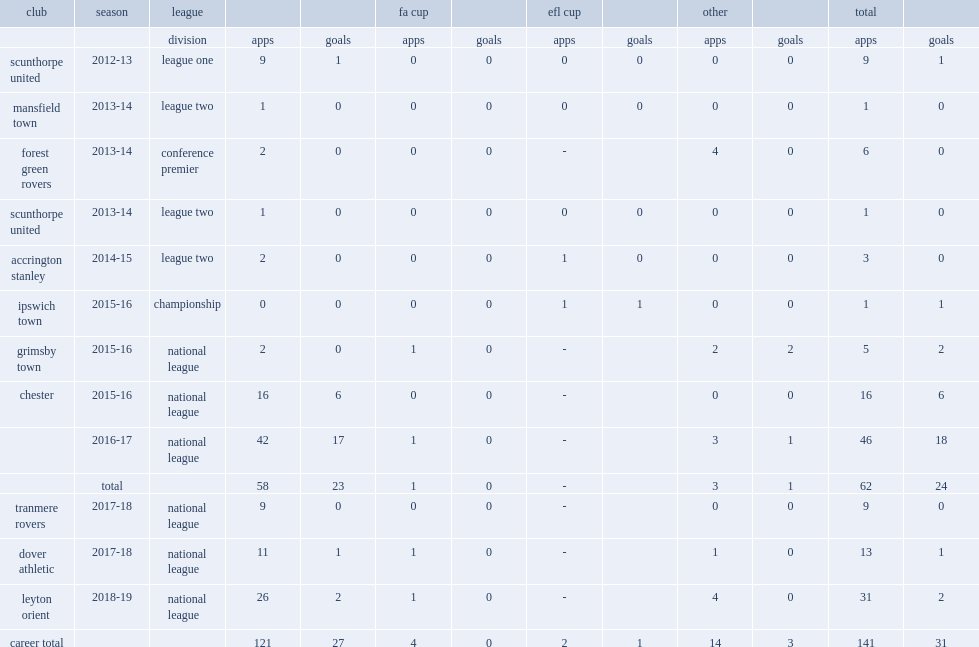Which league did alabi play for side chester in the 2015-16 season? National league. 